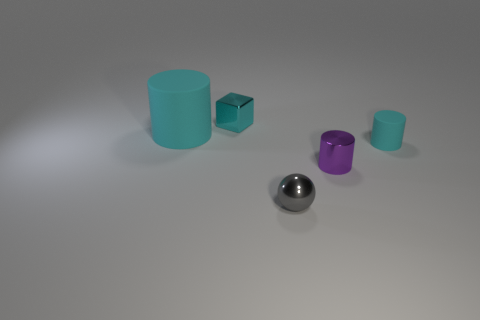Add 3 gray spheres. How many objects exist? 8 Subtract all blocks. How many objects are left? 4 Subtract all brown spheres. Subtract all tiny purple metallic cylinders. How many objects are left? 4 Add 1 large objects. How many large objects are left? 2 Add 1 shiny cylinders. How many shiny cylinders exist? 2 Subtract 1 purple cylinders. How many objects are left? 4 